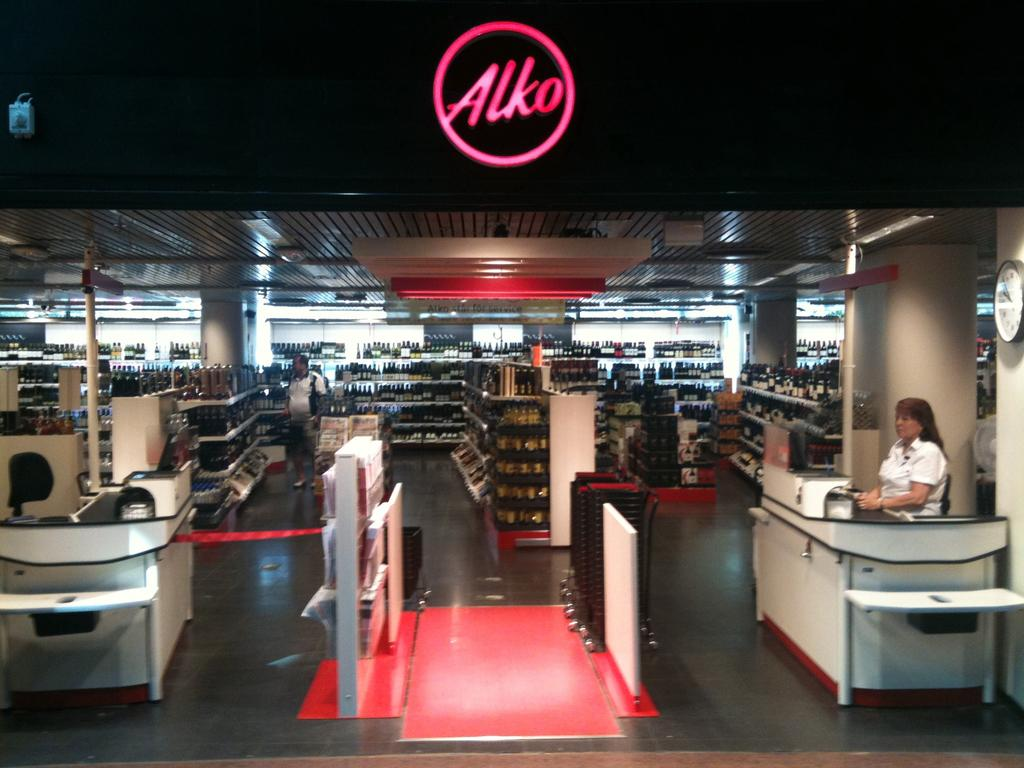Provide a one-sentence caption for the provided image. Woman waiting for customers in an Alko store. 